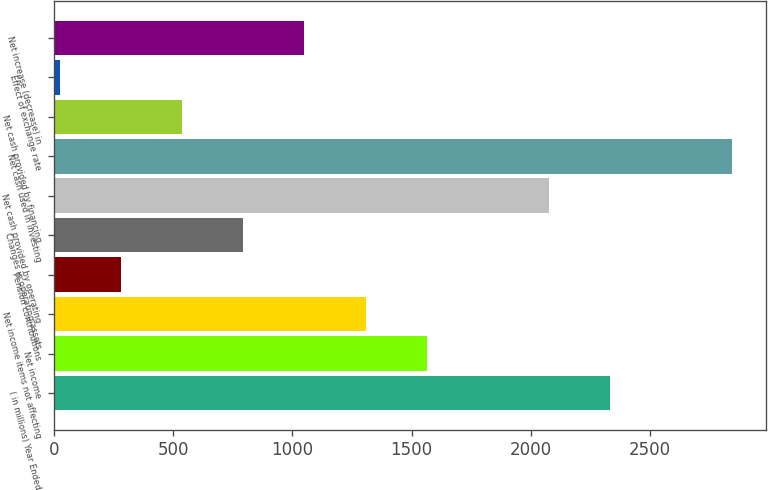Convert chart. <chart><loc_0><loc_0><loc_500><loc_500><bar_chart><fcel>( in millions) Year Ended<fcel>Net income<fcel>Net income items not affecting<fcel>Pension contributions<fcel>Changes in operating assets<fcel>Net cash provided by operating<fcel>Net cash used in investing<fcel>Net cash provided by financing<fcel>Effect of exchange rate<fcel>Net increase (decrease) in<nl><fcel>2331.72<fcel>1562.88<fcel>1306.6<fcel>281.48<fcel>794.04<fcel>2075.44<fcel>2844.28<fcel>537.76<fcel>25.2<fcel>1050.32<nl></chart> 